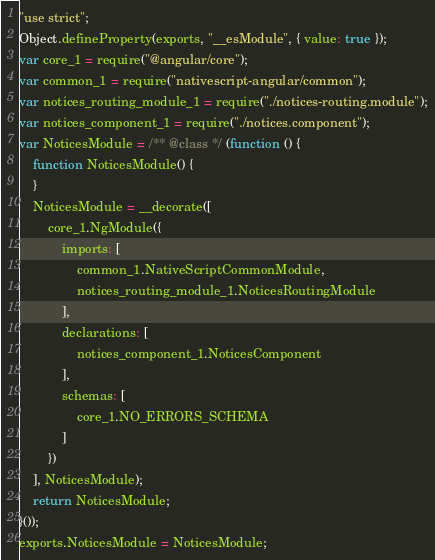<code> <loc_0><loc_0><loc_500><loc_500><_JavaScript_>"use strict";
Object.defineProperty(exports, "__esModule", { value: true });
var core_1 = require("@angular/core");
var common_1 = require("nativescript-angular/common");
var notices_routing_module_1 = require("./notices-routing.module");
var notices_component_1 = require("./notices.component");
var NoticesModule = /** @class */ (function () {
    function NoticesModule() {
    }
    NoticesModule = __decorate([
        core_1.NgModule({
            imports: [
                common_1.NativeScriptCommonModule,
                notices_routing_module_1.NoticesRoutingModule
            ],
            declarations: [
                notices_component_1.NoticesComponent
            ],
            schemas: [
                core_1.NO_ERRORS_SCHEMA
            ]
        })
    ], NoticesModule);
    return NoticesModule;
}());
exports.NoticesModule = NoticesModule;
</code> 